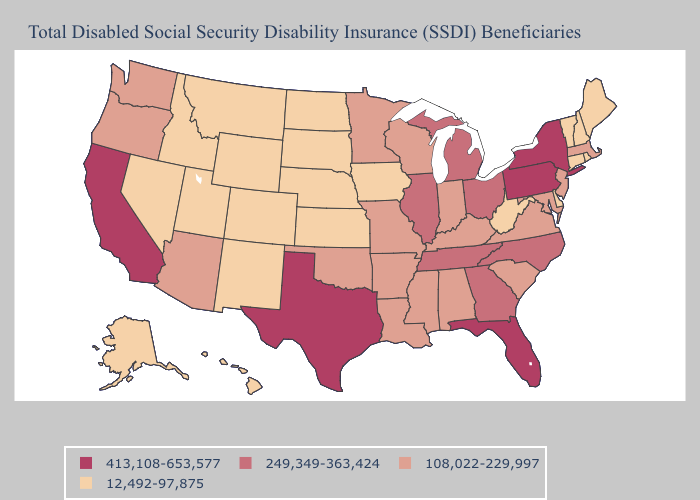Is the legend a continuous bar?
Give a very brief answer. No. Does Georgia have the highest value in the South?
Quick response, please. No. What is the lowest value in the USA?
Be succinct. 12,492-97,875. What is the lowest value in the USA?
Quick response, please. 12,492-97,875. What is the value of Missouri?
Short answer required. 108,022-229,997. Which states have the highest value in the USA?
Concise answer only. California, Florida, New York, Pennsylvania, Texas. What is the value of Idaho?
Concise answer only. 12,492-97,875. What is the value of Virginia?
Give a very brief answer. 108,022-229,997. What is the value of Iowa?
Quick response, please. 12,492-97,875. Which states have the highest value in the USA?
Keep it brief. California, Florida, New York, Pennsylvania, Texas. Name the states that have a value in the range 108,022-229,997?
Concise answer only. Alabama, Arizona, Arkansas, Indiana, Kentucky, Louisiana, Maryland, Massachusetts, Minnesota, Mississippi, Missouri, New Jersey, Oklahoma, Oregon, South Carolina, Virginia, Washington, Wisconsin. What is the value of North Dakota?
Short answer required. 12,492-97,875. What is the value of Louisiana?
Keep it brief. 108,022-229,997. Does Oregon have the same value as Delaware?
Be succinct. No. 